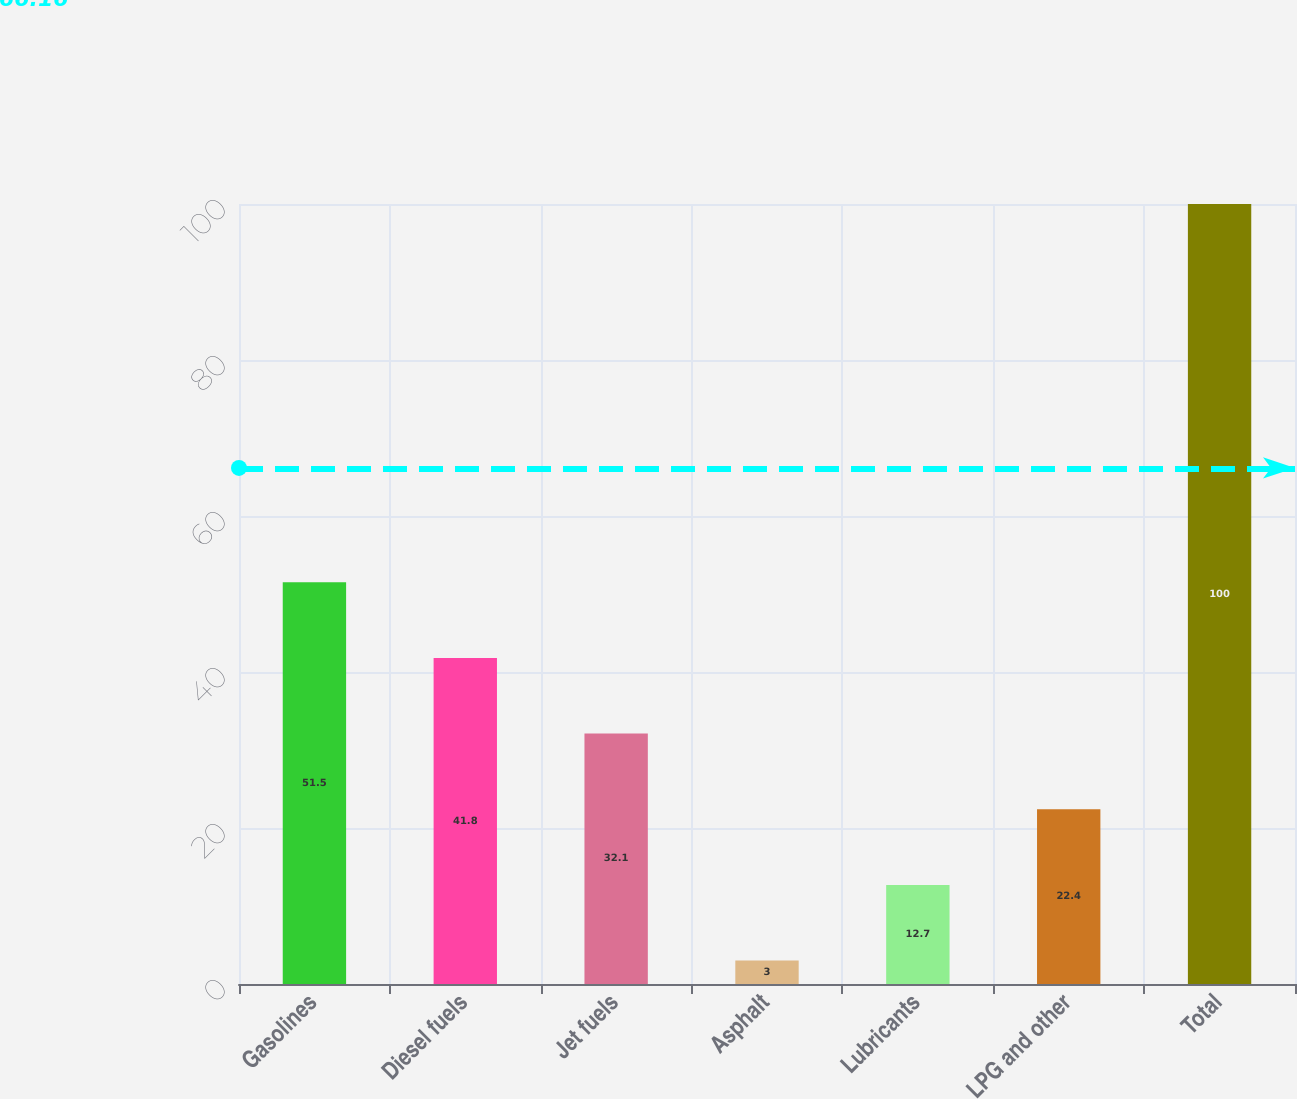Convert chart to OTSL. <chart><loc_0><loc_0><loc_500><loc_500><bar_chart><fcel>Gasolines<fcel>Diesel fuels<fcel>Jet fuels<fcel>Asphalt<fcel>Lubricants<fcel>LPG and other<fcel>Total<nl><fcel>51.5<fcel>41.8<fcel>32.1<fcel>3<fcel>12.7<fcel>22.4<fcel>100<nl></chart> 